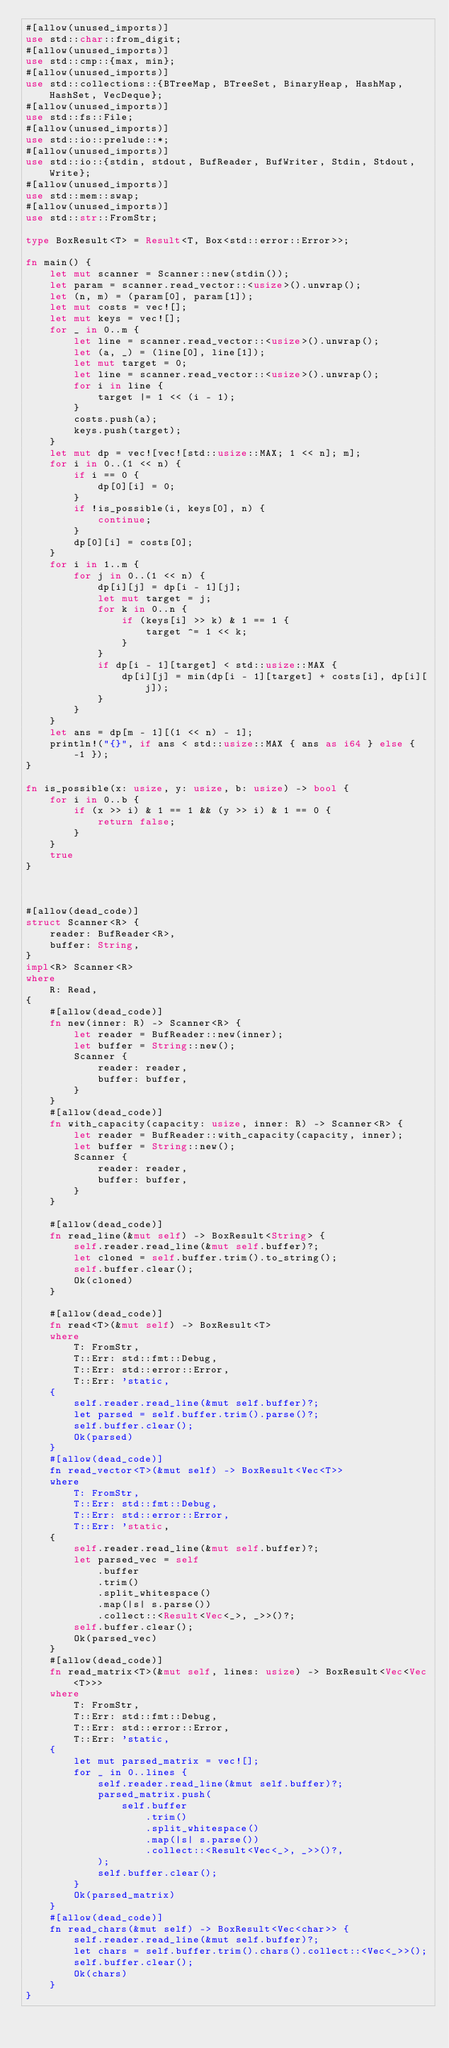<code> <loc_0><loc_0><loc_500><loc_500><_Rust_>#[allow(unused_imports)]
use std::char::from_digit;
#[allow(unused_imports)]
use std::cmp::{max, min};
#[allow(unused_imports)]
use std::collections::{BTreeMap, BTreeSet, BinaryHeap, HashMap, HashSet, VecDeque};
#[allow(unused_imports)]
use std::fs::File;
#[allow(unused_imports)]
use std::io::prelude::*;
#[allow(unused_imports)]
use std::io::{stdin, stdout, BufReader, BufWriter, Stdin, Stdout, Write};
#[allow(unused_imports)]
use std::mem::swap;
#[allow(unused_imports)]
use std::str::FromStr;

type BoxResult<T> = Result<T, Box<std::error::Error>>;

fn main() {
    let mut scanner = Scanner::new(stdin());
    let param = scanner.read_vector::<usize>().unwrap();
    let (n, m) = (param[0], param[1]);
    let mut costs = vec![];
    let mut keys = vec![];
    for _ in 0..m {
        let line = scanner.read_vector::<usize>().unwrap();
        let (a, _) = (line[0], line[1]);
        let mut target = 0;
        let line = scanner.read_vector::<usize>().unwrap();
        for i in line {
            target |= 1 << (i - 1);
        }
        costs.push(a);
        keys.push(target);
    }
    let mut dp = vec![vec![std::usize::MAX; 1 << n]; m];
    for i in 0..(1 << n) {
        if i == 0 {
            dp[0][i] = 0;
        }
        if !is_possible(i, keys[0], n) {
            continue;
        }
        dp[0][i] = costs[0];
    }
    for i in 1..m {
        for j in 0..(1 << n) {
            dp[i][j] = dp[i - 1][j];
            let mut target = j;
            for k in 0..n {
                if (keys[i] >> k) & 1 == 1 {
                    target ^= 1 << k;
                }
            }
            if dp[i - 1][target] < std::usize::MAX {
                dp[i][j] = min(dp[i - 1][target] + costs[i], dp[i][j]);
            }
        }
    }
    let ans = dp[m - 1][(1 << n) - 1];
    println!("{}", if ans < std::usize::MAX { ans as i64 } else { -1 });
}

fn is_possible(x: usize, y: usize, b: usize) -> bool {
    for i in 0..b {
        if (x >> i) & 1 == 1 && (y >> i) & 1 == 0 {
            return false;
        }
    }
    true
}



#[allow(dead_code)]
struct Scanner<R> {
    reader: BufReader<R>,
    buffer: String,
}
impl<R> Scanner<R>
where
    R: Read,
{
    #[allow(dead_code)]
    fn new(inner: R) -> Scanner<R> {
        let reader = BufReader::new(inner);
        let buffer = String::new();
        Scanner {
            reader: reader,
            buffer: buffer,
        }
    }
    #[allow(dead_code)]
    fn with_capacity(capacity: usize, inner: R) -> Scanner<R> {
        let reader = BufReader::with_capacity(capacity, inner);
        let buffer = String::new();
        Scanner {
            reader: reader,
            buffer: buffer,
        }
    }

    #[allow(dead_code)]
    fn read_line(&mut self) -> BoxResult<String> {
        self.reader.read_line(&mut self.buffer)?;
        let cloned = self.buffer.trim().to_string();
        self.buffer.clear();
        Ok(cloned)
    }

    #[allow(dead_code)]
    fn read<T>(&mut self) -> BoxResult<T>
    where
        T: FromStr,
        T::Err: std::fmt::Debug,
        T::Err: std::error::Error,
        T::Err: 'static,
    {
        self.reader.read_line(&mut self.buffer)?;
        let parsed = self.buffer.trim().parse()?;
        self.buffer.clear();
        Ok(parsed)
    }
    #[allow(dead_code)]
    fn read_vector<T>(&mut self) -> BoxResult<Vec<T>>
    where
        T: FromStr,
        T::Err: std::fmt::Debug,
        T::Err: std::error::Error,
        T::Err: 'static,
    {
        self.reader.read_line(&mut self.buffer)?;
        let parsed_vec = self
            .buffer
            .trim()
            .split_whitespace()
            .map(|s| s.parse())
            .collect::<Result<Vec<_>, _>>()?;
        self.buffer.clear();
        Ok(parsed_vec)
    }
    #[allow(dead_code)]
    fn read_matrix<T>(&mut self, lines: usize) -> BoxResult<Vec<Vec<T>>>
    where
        T: FromStr,
        T::Err: std::fmt::Debug,
        T::Err: std::error::Error,
        T::Err: 'static,
    {
        let mut parsed_matrix = vec![];
        for _ in 0..lines {
            self.reader.read_line(&mut self.buffer)?;
            parsed_matrix.push(
                self.buffer
                    .trim()
                    .split_whitespace()
                    .map(|s| s.parse())
                    .collect::<Result<Vec<_>, _>>()?,
            );
            self.buffer.clear();
        }
        Ok(parsed_matrix)
    }
    #[allow(dead_code)]
    fn read_chars(&mut self) -> BoxResult<Vec<char>> {
        self.reader.read_line(&mut self.buffer)?;
        let chars = self.buffer.trim().chars().collect::<Vec<_>>();
        self.buffer.clear();
        Ok(chars)
    }
}
</code> 